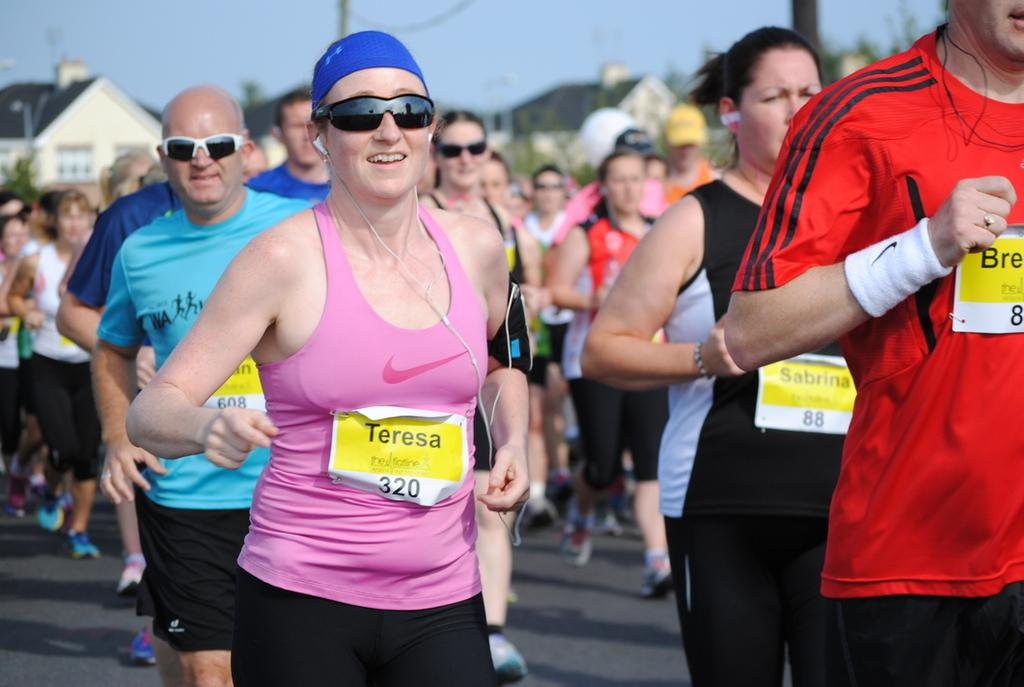How many people can be seen in the image? There are a few people in the image. What is visible beneath the people's feet? The ground is visible in the image. What type of structures are present in the image? There are houses in the image. What color are the objects in the image? There are green colored objects in the image. What else can be seen in the image besides the people and houses? There are poles in the image. What is visible above the houses and poles? The sky is visible in the image. What type of instrument is being played by the owl in the image? There is no owl or instrument present in the image. 